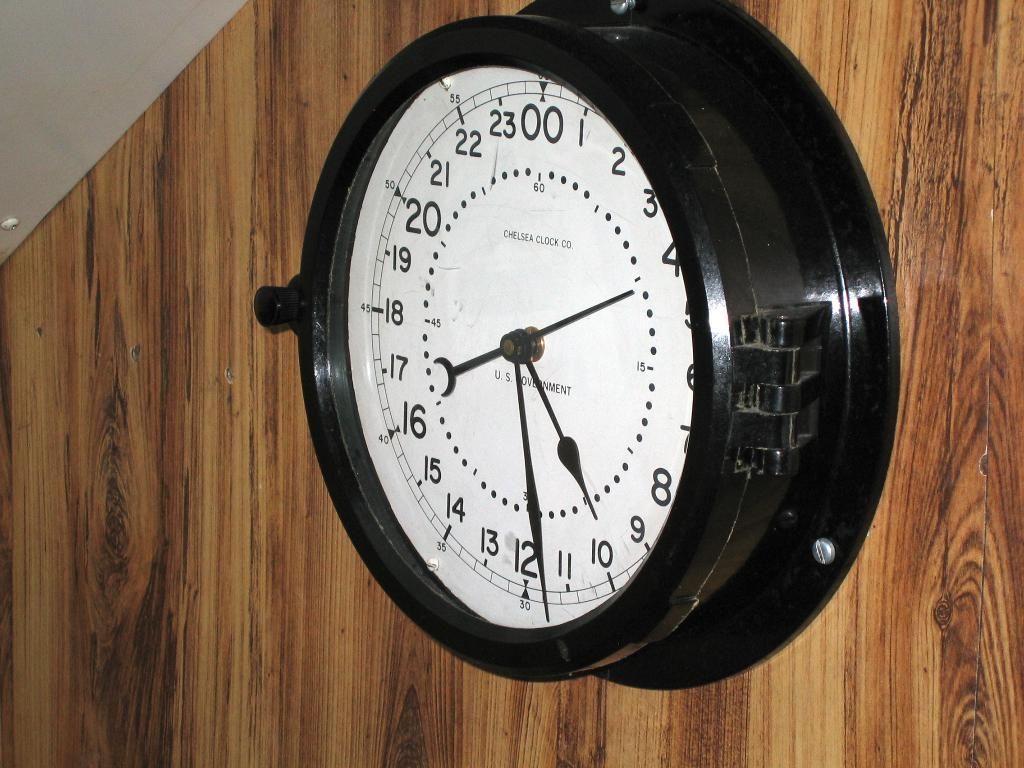<image>
Render a clear and concise summary of the photo. The clock shows one hand at around 10 and another at around 12. 